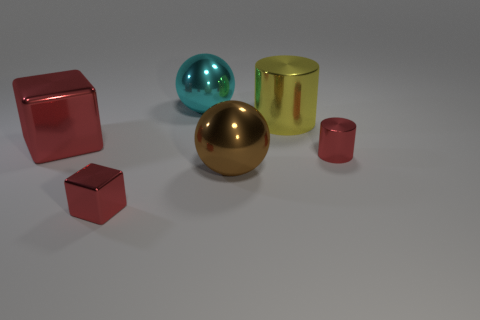Add 1 big matte cylinders. How many objects exist? 7 Subtract all cylinders. How many objects are left? 4 Add 1 large cyan spheres. How many large cyan spheres exist? 2 Subtract 1 brown spheres. How many objects are left? 5 Subtract all tiny red metallic blocks. Subtract all cyan shiny balls. How many objects are left? 4 Add 6 large cylinders. How many large cylinders are left? 7 